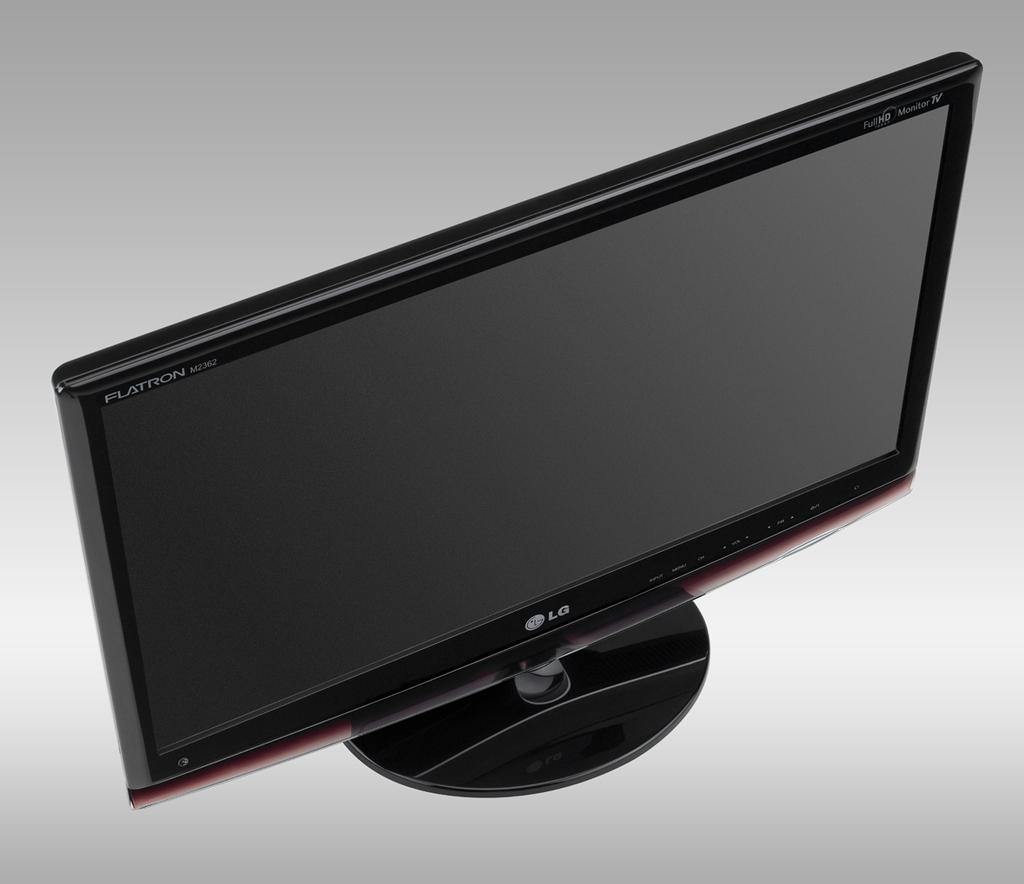<image>
Give a short and clear explanation of the subsequent image. A tv on a white surface and background with the word LG on it. 